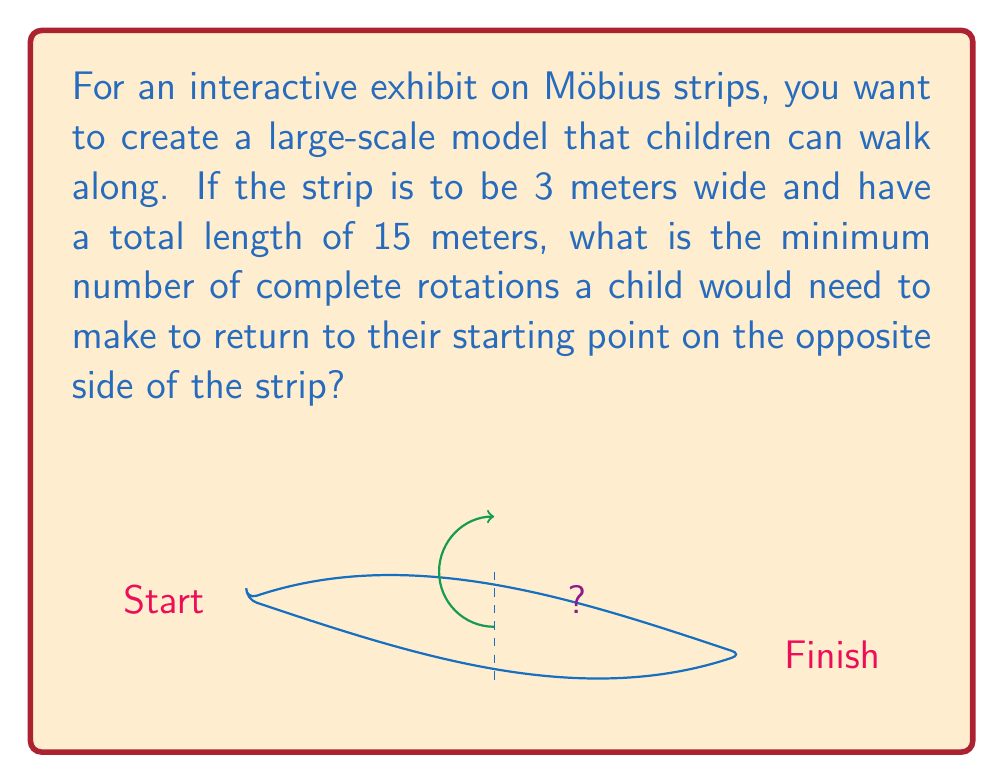Can you answer this question? Let's approach this step-by-step:

1) First, recall that a Möbius strip has only one side and one edge. To return to the starting point on the "opposite" side, you actually need to traverse the entire strip twice.

2) The total length of the path to return to the starting point on the opposite side is:

   $$\text{Total path length} = 2 \times \text{Strip length} = 2 \times 15 = 30 \text{ meters}$$

3) Now, we need to determine how many rotations this represents. One full rotation would be equivalent to traveling the width of the strip twice (once on each "side").

4) The circumference of one rotation is:

   $$\text{Rotation circumference} = 2 \times \text{Strip width} = 2 \times 3 = 6 \text{ meters}$$

5) To find the number of rotations, we divide the total path length by the circumference of one rotation:

   $$\text{Number of rotations} = \frac{\text{Total path length}}{\text{Rotation circumference}} = \frac{30}{6} = 5$$

6) Therefore, a child would need to make 5 complete rotations to return to their starting point on the opposite side of the strip.

This concept demonstrates the unique topological properties of a Möbius strip, where the "inside" becomes the "outside" after one complete traversal of the strip's length.
Answer: 5 rotations 